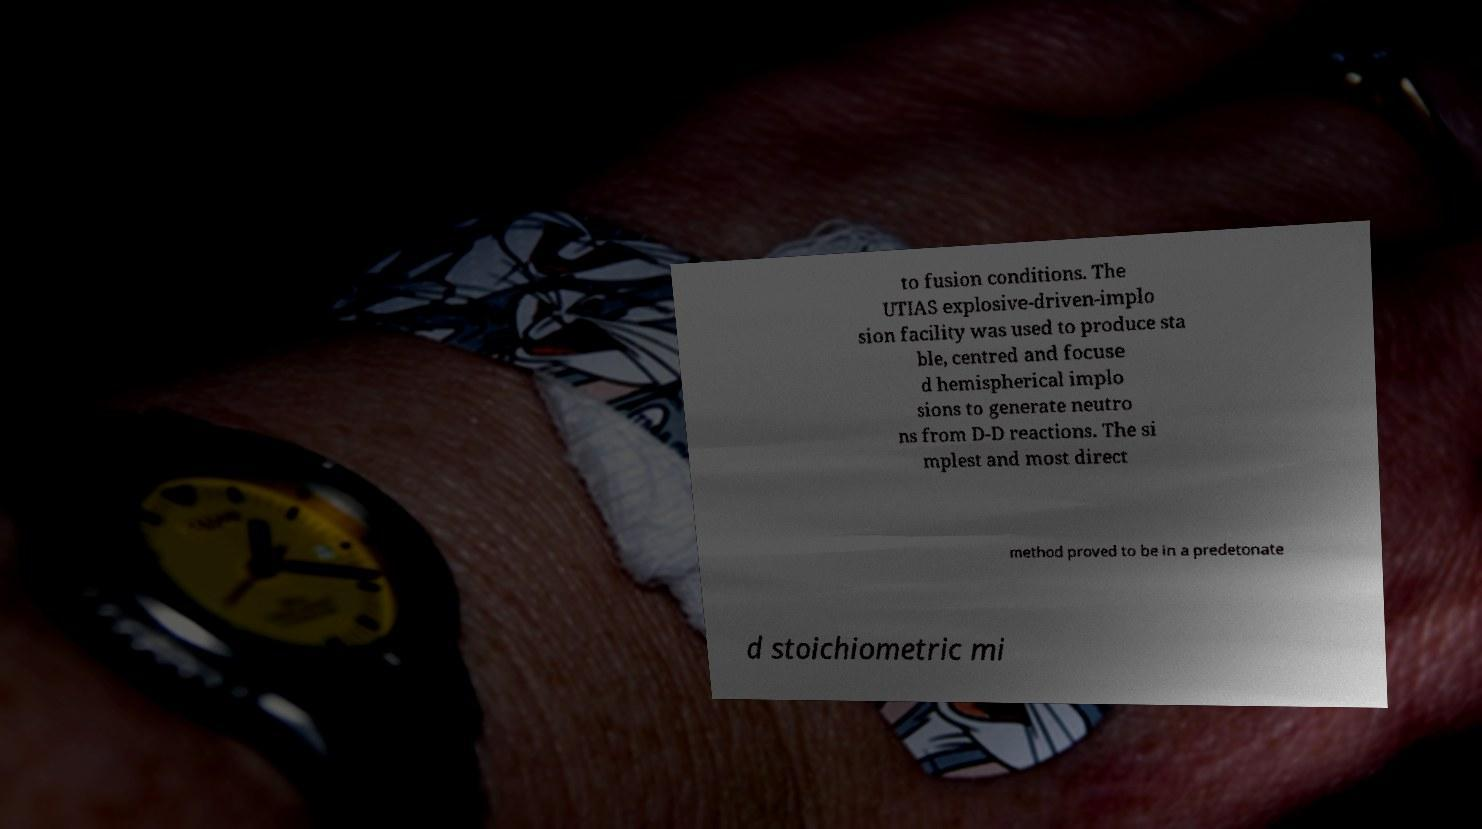Could you extract and type out the text from this image? to fusion conditions. The UTIAS explosive-driven-implo sion facility was used to produce sta ble, centred and focuse d hemispherical implo sions to generate neutro ns from D-D reactions. The si mplest and most direct method proved to be in a predetonate d stoichiometric mi 